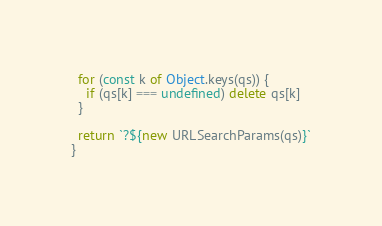Convert code to text. <code><loc_0><loc_0><loc_500><loc_500><_TypeScript_>  for (const k of Object.keys(qs)) {
    if (qs[k] === undefined) delete qs[k]
  }

  return `?${new URLSearchParams(qs)}`
}
</code> 